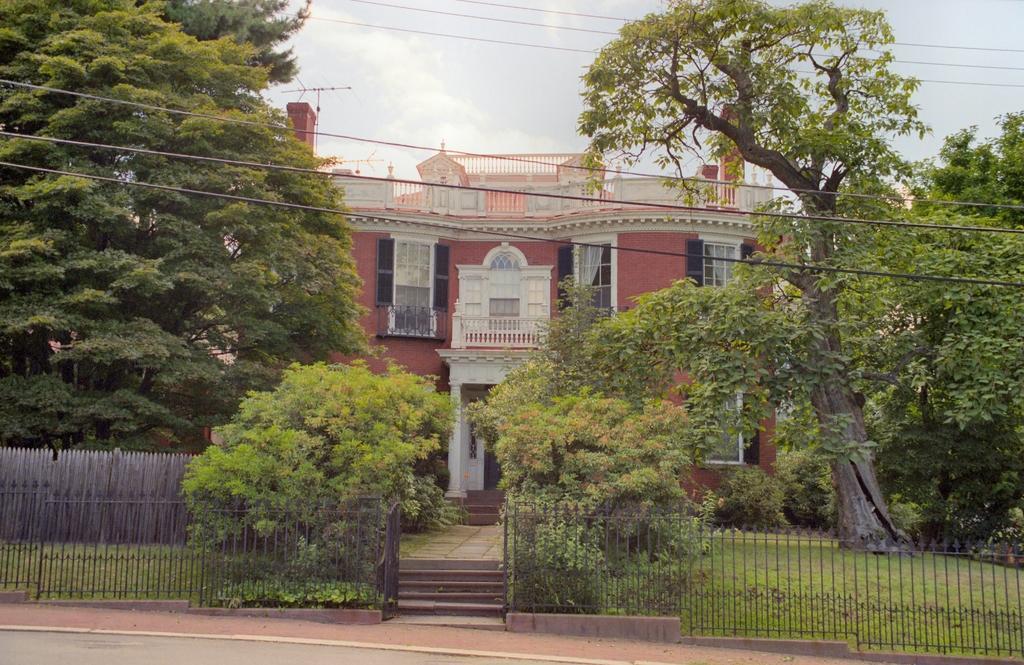Can you describe this image briefly? In this image there is a building, on top of the building there are antennas, in front of the building there are trees and there is a wooden fence, in front of the wooden fence there is a metal rod fence, in front of the image there is a road, beside the road there is a pavement, in front of the pavement there are stairs, at the top of the image there are cables and clouds in the sky. 